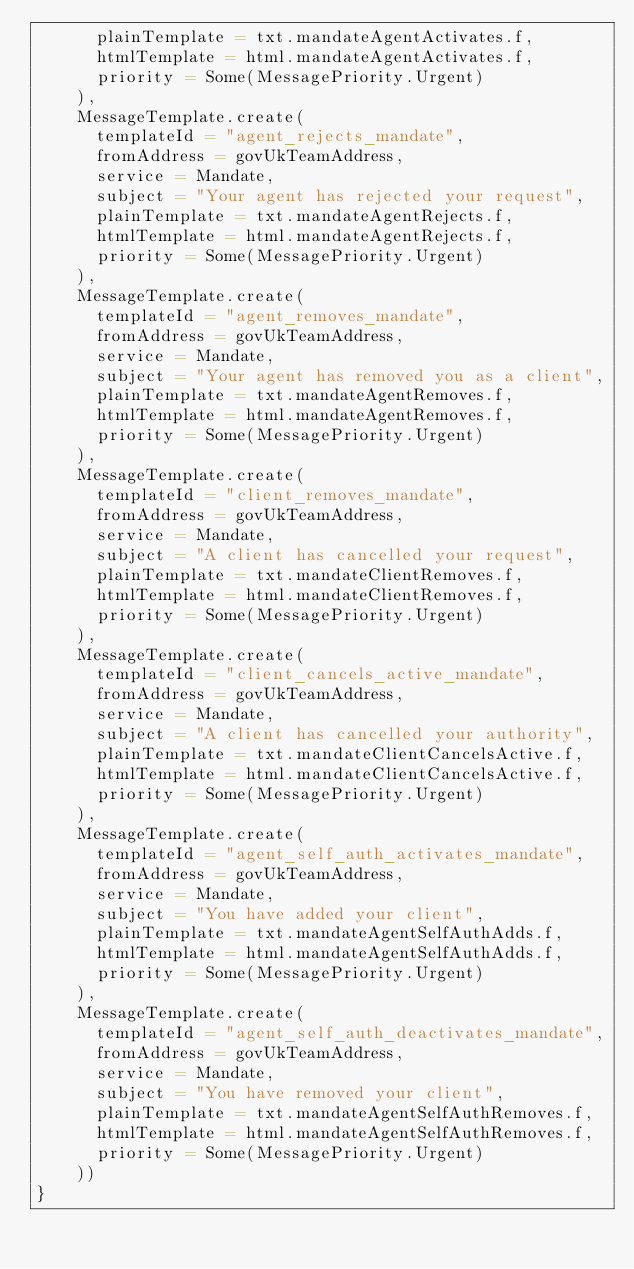Convert code to text. <code><loc_0><loc_0><loc_500><loc_500><_Scala_>      plainTemplate = txt.mandateAgentActivates.f,
      htmlTemplate = html.mandateAgentActivates.f,
      priority = Some(MessagePriority.Urgent)
    ),
    MessageTemplate.create(
      templateId = "agent_rejects_mandate",
      fromAddress = govUkTeamAddress,
      service = Mandate,
      subject = "Your agent has rejected your request",
      plainTemplate = txt.mandateAgentRejects.f,
      htmlTemplate = html.mandateAgentRejects.f,
      priority = Some(MessagePriority.Urgent)
    ),
    MessageTemplate.create(
      templateId = "agent_removes_mandate",
      fromAddress = govUkTeamAddress,
      service = Mandate,
      subject = "Your agent has removed you as a client",
      plainTemplate = txt.mandateAgentRemoves.f,
      htmlTemplate = html.mandateAgentRemoves.f,
      priority = Some(MessagePriority.Urgent)
    ),
    MessageTemplate.create(
      templateId = "client_removes_mandate",
      fromAddress = govUkTeamAddress,
      service = Mandate,
      subject = "A client has cancelled your request",
      plainTemplate = txt.mandateClientRemoves.f,
      htmlTemplate = html.mandateClientRemoves.f,
      priority = Some(MessagePriority.Urgent)
    ),
    MessageTemplate.create(
      templateId = "client_cancels_active_mandate",
      fromAddress = govUkTeamAddress,
      service = Mandate,
      subject = "A client has cancelled your authority",
      plainTemplate = txt.mandateClientCancelsActive.f,
      htmlTemplate = html.mandateClientCancelsActive.f,
      priority = Some(MessagePriority.Urgent)
    ),
    MessageTemplate.create(
      templateId = "agent_self_auth_activates_mandate",
      fromAddress = govUkTeamAddress,
      service = Mandate,
      subject = "You have added your client",
      plainTemplate = txt.mandateAgentSelfAuthAdds.f,
      htmlTemplate = html.mandateAgentSelfAuthAdds.f,
      priority = Some(MessagePriority.Urgent)
    ),
    MessageTemplate.create(
      templateId = "agent_self_auth_deactivates_mandate",
      fromAddress = govUkTeamAddress,
      service = Mandate,
      subject = "You have removed your client",
      plainTemplate = txt.mandateAgentSelfAuthRemoves.f,
      htmlTemplate = html.mandateAgentSelfAuthRemoves.f,
      priority = Some(MessagePriority.Urgent)
    ))
}
</code> 